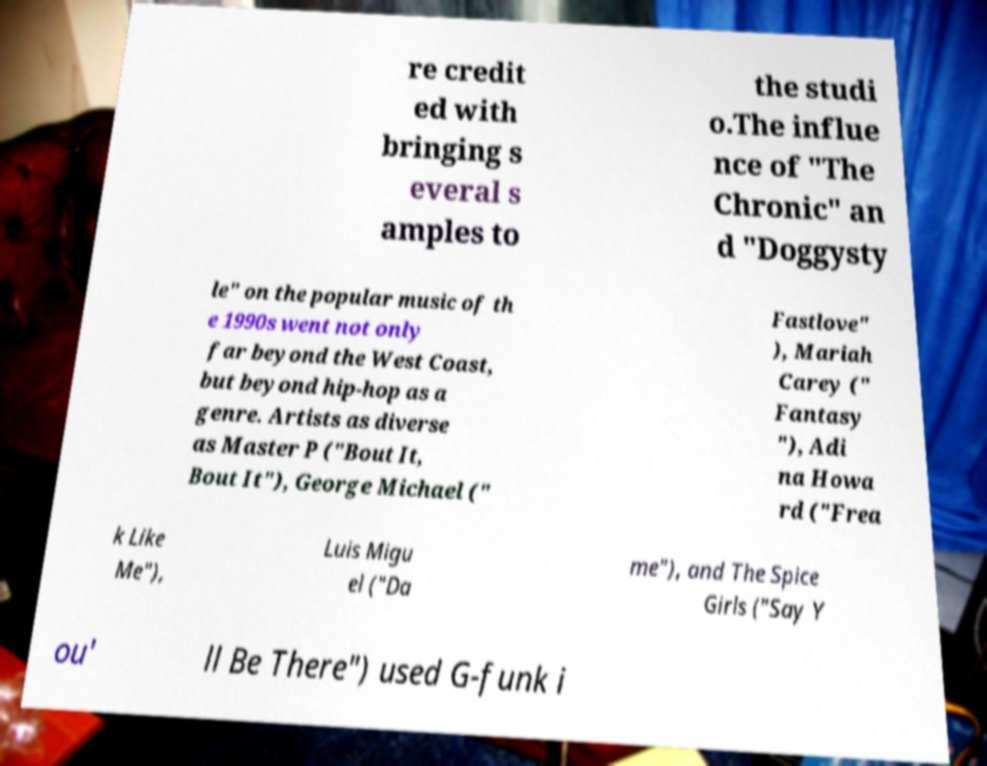Could you assist in decoding the text presented in this image and type it out clearly? re credit ed with bringing s everal s amples to the studi o.The influe nce of "The Chronic" an d "Doggysty le" on the popular music of th e 1990s went not only far beyond the West Coast, but beyond hip-hop as a genre. Artists as diverse as Master P ("Bout It, Bout It"), George Michael (" Fastlove" ), Mariah Carey (" Fantasy "), Adi na Howa rd ("Frea k Like Me"), Luis Migu el ("Da me"), and The Spice Girls ("Say Y ou' ll Be There") used G-funk i 